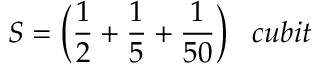Convert formula to latex. <formula><loc_0><loc_0><loc_500><loc_500>S = { \left ( } { \frac { 1 } { 2 } } + { \frac { 1 } { 5 } } + { \frac { 1 } { 5 0 } } { \right ) } \, c u b i t</formula> 